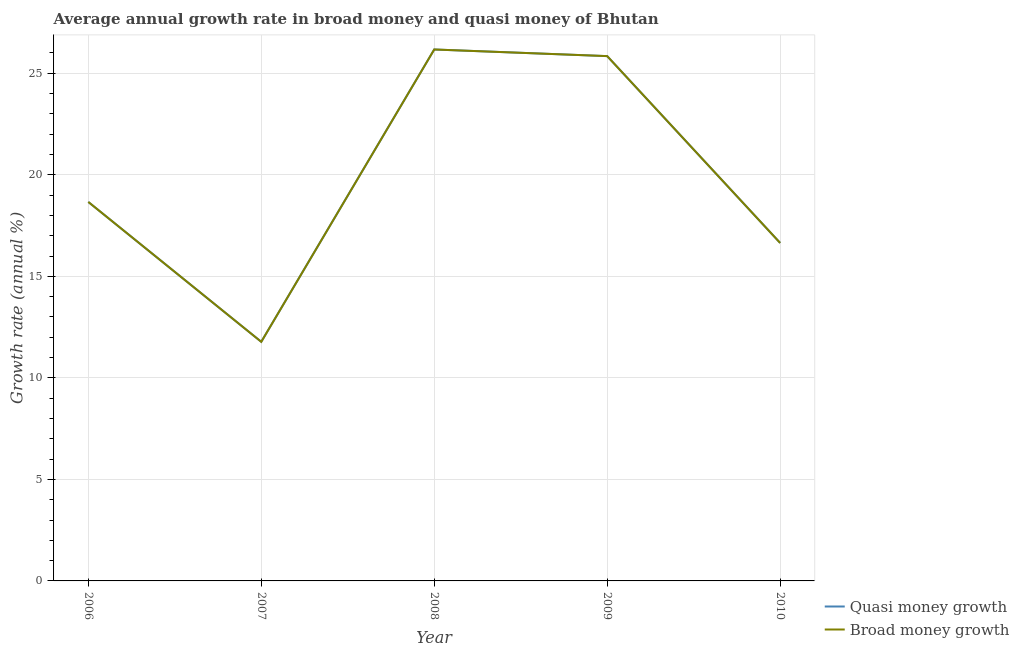Does the line corresponding to annual growth rate in quasi money intersect with the line corresponding to annual growth rate in broad money?
Keep it short and to the point. Yes. Is the number of lines equal to the number of legend labels?
Your response must be concise. Yes. What is the annual growth rate in quasi money in 2006?
Your answer should be compact. 18.66. Across all years, what is the maximum annual growth rate in quasi money?
Keep it short and to the point. 26.17. Across all years, what is the minimum annual growth rate in broad money?
Give a very brief answer. 11.78. In which year was the annual growth rate in broad money maximum?
Ensure brevity in your answer.  2008. What is the total annual growth rate in quasi money in the graph?
Your answer should be compact. 99.1. What is the difference between the annual growth rate in quasi money in 2008 and that in 2009?
Give a very brief answer. 0.33. What is the difference between the annual growth rate in quasi money in 2006 and the annual growth rate in broad money in 2009?
Provide a short and direct response. -7.18. What is the average annual growth rate in broad money per year?
Ensure brevity in your answer.  19.82. In the year 2008, what is the difference between the annual growth rate in quasi money and annual growth rate in broad money?
Offer a very short reply. 0. What is the ratio of the annual growth rate in quasi money in 2006 to that in 2008?
Offer a terse response. 0.71. Is the annual growth rate in quasi money in 2007 less than that in 2008?
Provide a short and direct response. Yes. Is the difference between the annual growth rate in broad money in 2007 and 2009 greater than the difference between the annual growth rate in quasi money in 2007 and 2009?
Your answer should be very brief. No. What is the difference between the highest and the second highest annual growth rate in quasi money?
Provide a short and direct response. 0.33. What is the difference between the highest and the lowest annual growth rate in broad money?
Your answer should be compact. 14.4. In how many years, is the annual growth rate in broad money greater than the average annual growth rate in broad money taken over all years?
Your response must be concise. 2. Does the annual growth rate in quasi money monotonically increase over the years?
Provide a short and direct response. No. How many years are there in the graph?
Provide a succinct answer. 5. What is the title of the graph?
Your answer should be compact. Average annual growth rate in broad money and quasi money of Bhutan. Does "Registered firms" appear as one of the legend labels in the graph?
Make the answer very short. No. What is the label or title of the Y-axis?
Ensure brevity in your answer.  Growth rate (annual %). What is the Growth rate (annual %) in Quasi money growth in 2006?
Ensure brevity in your answer.  18.66. What is the Growth rate (annual %) in Broad money growth in 2006?
Offer a very short reply. 18.66. What is the Growth rate (annual %) in Quasi money growth in 2007?
Your answer should be compact. 11.78. What is the Growth rate (annual %) of Broad money growth in 2007?
Provide a short and direct response. 11.78. What is the Growth rate (annual %) in Quasi money growth in 2008?
Keep it short and to the point. 26.17. What is the Growth rate (annual %) in Broad money growth in 2008?
Give a very brief answer. 26.17. What is the Growth rate (annual %) in Quasi money growth in 2009?
Your answer should be very brief. 25.84. What is the Growth rate (annual %) of Broad money growth in 2009?
Your answer should be very brief. 25.84. What is the Growth rate (annual %) in Quasi money growth in 2010?
Give a very brief answer. 16.64. What is the Growth rate (annual %) of Broad money growth in 2010?
Give a very brief answer. 16.64. Across all years, what is the maximum Growth rate (annual %) of Quasi money growth?
Give a very brief answer. 26.17. Across all years, what is the maximum Growth rate (annual %) of Broad money growth?
Offer a very short reply. 26.17. Across all years, what is the minimum Growth rate (annual %) of Quasi money growth?
Ensure brevity in your answer.  11.78. Across all years, what is the minimum Growth rate (annual %) in Broad money growth?
Your answer should be very brief. 11.78. What is the total Growth rate (annual %) of Quasi money growth in the graph?
Ensure brevity in your answer.  99.1. What is the total Growth rate (annual %) in Broad money growth in the graph?
Give a very brief answer. 99.1. What is the difference between the Growth rate (annual %) in Quasi money growth in 2006 and that in 2007?
Your answer should be compact. 6.89. What is the difference between the Growth rate (annual %) in Broad money growth in 2006 and that in 2007?
Offer a very short reply. 6.89. What is the difference between the Growth rate (annual %) in Quasi money growth in 2006 and that in 2008?
Your answer should be very brief. -7.51. What is the difference between the Growth rate (annual %) of Broad money growth in 2006 and that in 2008?
Provide a succinct answer. -7.51. What is the difference between the Growth rate (annual %) in Quasi money growth in 2006 and that in 2009?
Offer a terse response. -7.18. What is the difference between the Growth rate (annual %) of Broad money growth in 2006 and that in 2009?
Offer a terse response. -7.18. What is the difference between the Growth rate (annual %) of Quasi money growth in 2006 and that in 2010?
Your response must be concise. 2.02. What is the difference between the Growth rate (annual %) of Broad money growth in 2006 and that in 2010?
Give a very brief answer. 2.02. What is the difference between the Growth rate (annual %) of Quasi money growth in 2007 and that in 2008?
Provide a short and direct response. -14.4. What is the difference between the Growth rate (annual %) of Broad money growth in 2007 and that in 2008?
Offer a very short reply. -14.4. What is the difference between the Growth rate (annual %) of Quasi money growth in 2007 and that in 2009?
Provide a short and direct response. -14.07. What is the difference between the Growth rate (annual %) of Broad money growth in 2007 and that in 2009?
Ensure brevity in your answer.  -14.07. What is the difference between the Growth rate (annual %) in Quasi money growth in 2007 and that in 2010?
Provide a short and direct response. -4.87. What is the difference between the Growth rate (annual %) of Broad money growth in 2007 and that in 2010?
Ensure brevity in your answer.  -4.87. What is the difference between the Growth rate (annual %) in Quasi money growth in 2008 and that in 2009?
Provide a succinct answer. 0.33. What is the difference between the Growth rate (annual %) of Broad money growth in 2008 and that in 2009?
Your answer should be compact. 0.33. What is the difference between the Growth rate (annual %) of Quasi money growth in 2008 and that in 2010?
Give a very brief answer. 9.53. What is the difference between the Growth rate (annual %) in Broad money growth in 2008 and that in 2010?
Provide a succinct answer. 9.53. What is the difference between the Growth rate (annual %) of Quasi money growth in 2009 and that in 2010?
Provide a short and direct response. 9.2. What is the difference between the Growth rate (annual %) in Broad money growth in 2009 and that in 2010?
Your answer should be compact. 9.2. What is the difference between the Growth rate (annual %) of Quasi money growth in 2006 and the Growth rate (annual %) of Broad money growth in 2007?
Make the answer very short. 6.89. What is the difference between the Growth rate (annual %) of Quasi money growth in 2006 and the Growth rate (annual %) of Broad money growth in 2008?
Offer a terse response. -7.51. What is the difference between the Growth rate (annual %) in Quasi money growth in 2006 and the Growth rate (annual %) in Broad money growth in 2009?
Make the answer very short. -7.18. What is the difference between the Growth rate (annual %) in Quasi money growth in 2006 and the Growth rate (annual %) in Broad money growth in 2010?
Keep it short and to the point. 2.02. What is the difference between the Growth rate (annual %) of Quasi money growth in 2007 and the Growth rate (annual %) of Broad money growth in 2008?
Offer a terse response. -14.4. What is the difference between the Growth rate (annual %) of Quasi money growth in 2007 and the Growth rate (annual %) of Broad money growth in 2009?
Your response must be concise. -14.07. What is the difference between the Growth rate (annual %) in Quasi money growth in 2007 and the Growth rate (annual %) in Broad money growth in 2010?
Offer a very short reply. -4.87. What is the difference between the Growth rate (annual %) in Quasi money growth in 2008 and the Growth rate (annual %) in Broad money growth in 2009?
Give a very brief answer. 0.33. What is the difference between the Growth rate (annual %) of Quasi money growth in 2008 and the Growth rate (annual %) of Broad money growth in 2010?
Ensure brevity in your answer.  9.53. What is the difference between the Growth rate (annual %) in Quasi money growth in 2009 and the Growth rate (annual %) in Broad money growth in 2010?
Offer a terse response. 9.2. What is the average Growth rate (annual %) of Quasi money growth per year?
Make the answer very short. 19.82. What is the average Growth rate (annual %) of Broad money growth per year?
Provide a short and direct response. 19.82. In the year 2009, what is the difference between the Growth rate (annual %) of Quasi money growth and Growth rate (annual %) of Broad money growth?
Ensure brevity in your answer.  0. What is the ratio of the Growth rate (annual %) in Quasi money growth in 2006 to that in 2007?
Your answer should be compact. 1.58. What is the ratio of the Growth rate (annual %) of Broad money growth in 2006 to that in 2007?
Offer a very short reply. 1.58. What is the ratio of the Growth rate (annual %) of Quasi money growth in 2006 to that in 2008?
Provide a short and direct response. 0.71. What is the ratio of the Growth rate (annual %) in Broad money growth in 2006 to that in 2008?
Your response must be concise. 0.71. What is the ratio of the Growth rate (annual %) in Quasi money growth in 2006 to that in 2009?
Offer a very short reply. 0.72. What is the ratio of the Growth rate (annual %) of Broad money growth in 2006 to that in 2009?
Provide a succinct answer. 0.72. What is the ratio of the Growth rate (annual %) in Quasi money growth in 2006 to that in 2010?
Your answer should be compact. 1.12. What is the ratio of the Growth rate (annual %) in Broad money growth in 2006 to that in 2010?
Your response must be concise. 1.12. What is the ratio of the Growth rate (annual %) of Quasi money growth in 2007 to that in 2008?
Your response must be concise. 0.45. What is the ratio of the Growth rate (annual %) of Broad money growth in 2007 to that in 2008?
Ensure brevity in your answer.  0.45. What is the ratio of the Growth rate (annual %) of Quasi money growth in 2007 to that in 2009?
Offer a terse response. 0.46. What is the ratio of the Growth rate (annual %) in Broad money growth in 2007 to that in 2009?
Provide a short and direct response. 0.46. What is the ratio of the Growth rate (annual %) of Quasi money growth in 2007 to that in 2010?
Keep it short and to the point. 0.71. What is the ratio of the Growth rate (annual %) in Broad money growth in 2007 to that in 2010?
Make the answer very short. 0.71. What is the ratio of the Growth rate (annual %) of Quasi money growth in 2008 to that in 2009?
Your response must be concise. 1.01. What is the ratio of the Growth rate (annual %) in Broad money growth in 2008 to that in 2009?
Provide a succinct answer. 1.01. What is the ratio of the Growth rate (annual %) in Quasi money growth in 2008 to that in 2010?
Ensure brevity in your answer.  1.57. What is the ratio of the Growth rate (annual %) of Broad money growth in 2008 to that in 2010?
Offer a terse response. 1.57. What is the ratio of the Growth rate (annual %) of Quasi money growth in 2009 to that in 2010?
Provide a short and direct response. 1.55. What is the ratio of the Growth rate (annual %) in Broad money growth in 2009 to that in 2010?
Provide a succinct answer. 1.55. What is the difference between the highest and the second highest Growth rate (annual %) in Quasi money growth?
Offer a very short reply. 0.33. What is the difference between the highest and the second highest Growth rate (annual %) in Broad money growth?
Provide a short and direct response. 0.33. What is the difference between the highest and the lowest Growth rate (annual %) in Quasi money growth?
Your answer should be very brief. 14.4. What is the difference between the highest and the lowest Growth rate (annual %) in Broad money growth?
Your answer should be compact. 14.4. 